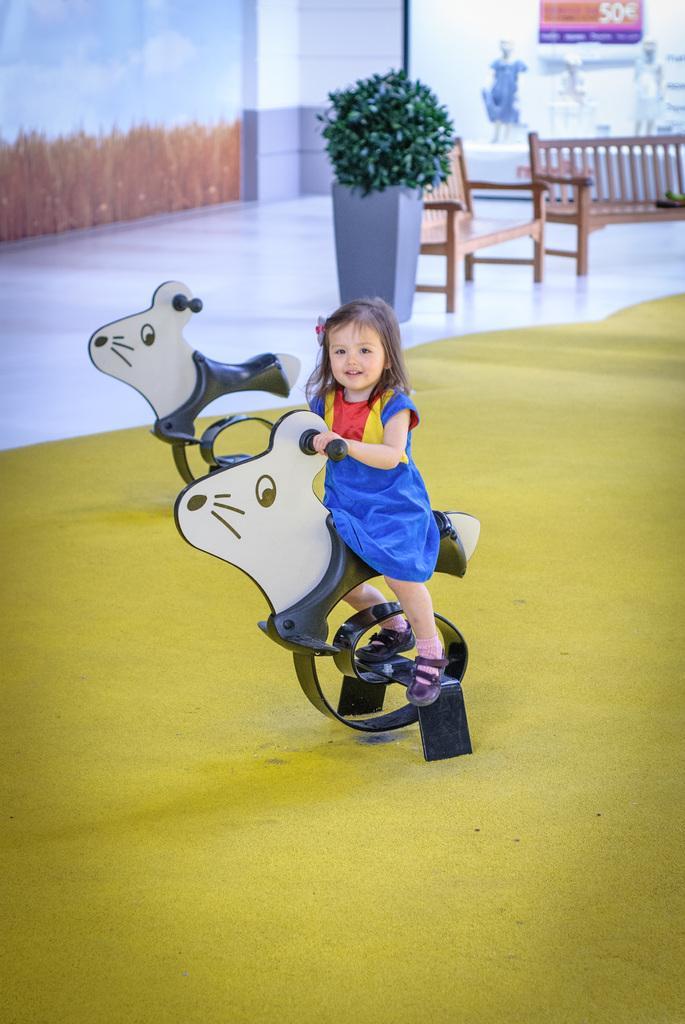How would you summarize this image in a sentence or two? In this picture we can see the small girl wearing a blue dress is sitting on the toy horse. Behind there is a wooden bench and planter pot. In the background we can see some statue in the shop. 